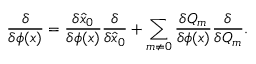<formula> <loc_0><loc_0><loc_500><loc_500>{ \frac { \delta } { \delta \phi ( x ) } } = { \frac { \delta \hat { x } _ { 0 } } { \delta \phi ( x ) } } { \frac { \delta } { \delta \hat { x } _ { 0 } } } + \sum _ { m \neq 0 } { \frac { \delta Q _ { m } } { \delta \phi ( x ) } } { \frac { \delta } { \delta Q _ { m } } } .</formula> 